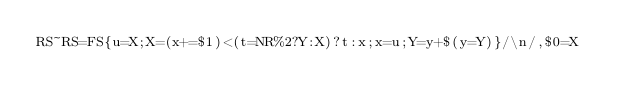<code> <loc_0><loc_0><loc_500><loc_500><_Awk_>RS~RS=FS{u=X;X=(x+=$1)<(t=NR%2?Y:X)?t:x;x=u;Y=y+$(y=Y)}/\n/,$0=X</code> 